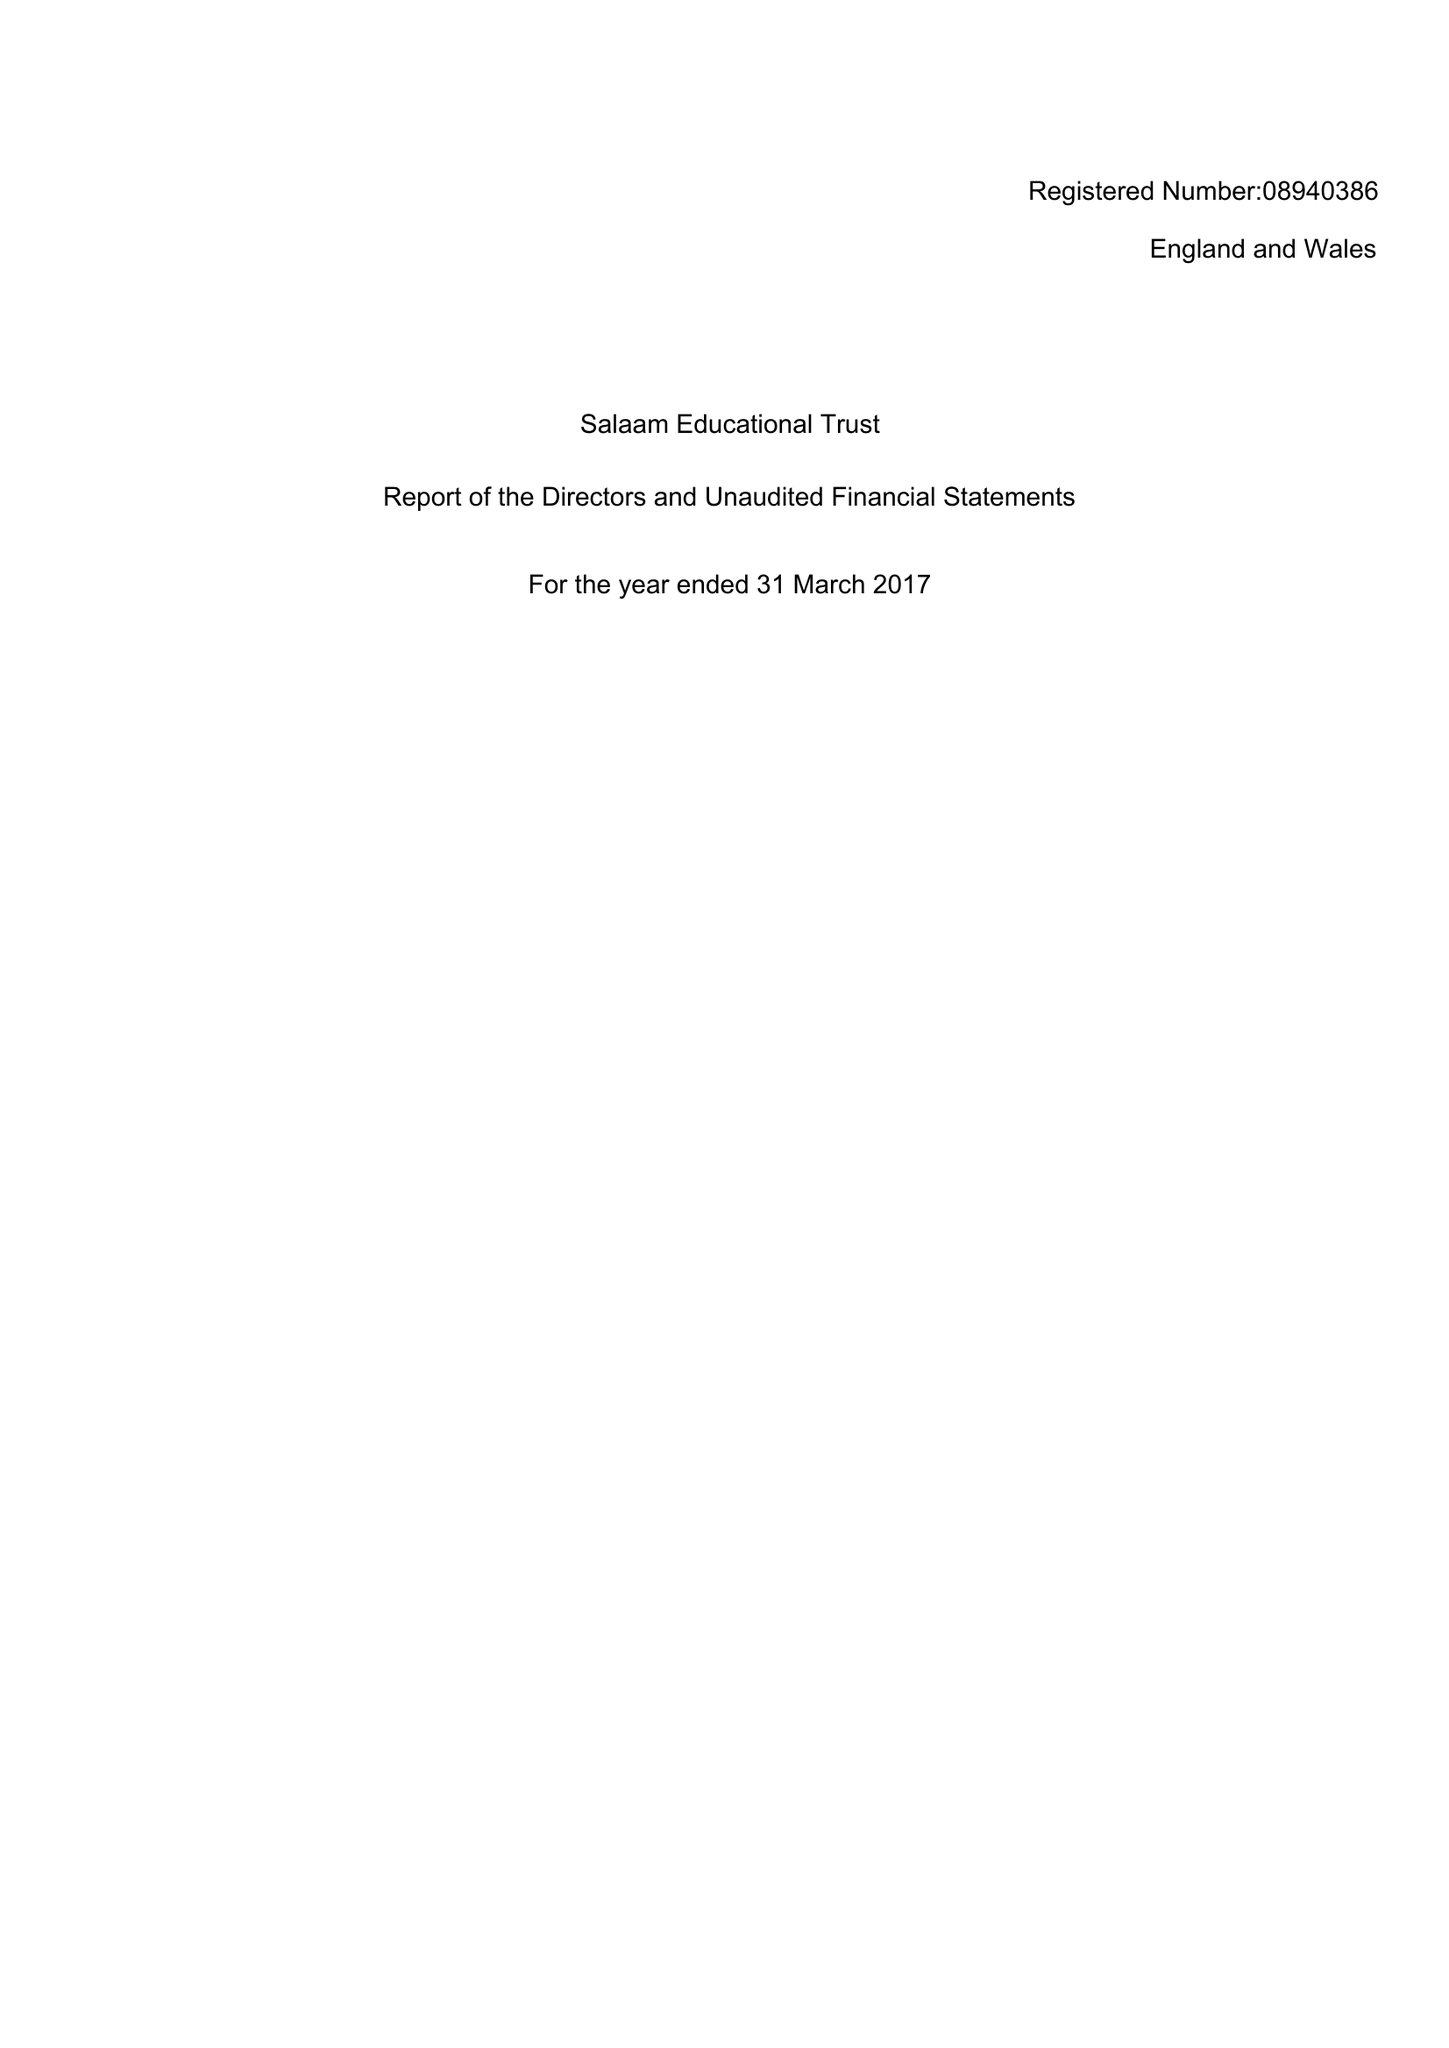What is the value for the spending_annually_in_british_pounds?
Answer the question using a single word or phrase. 19700.00 